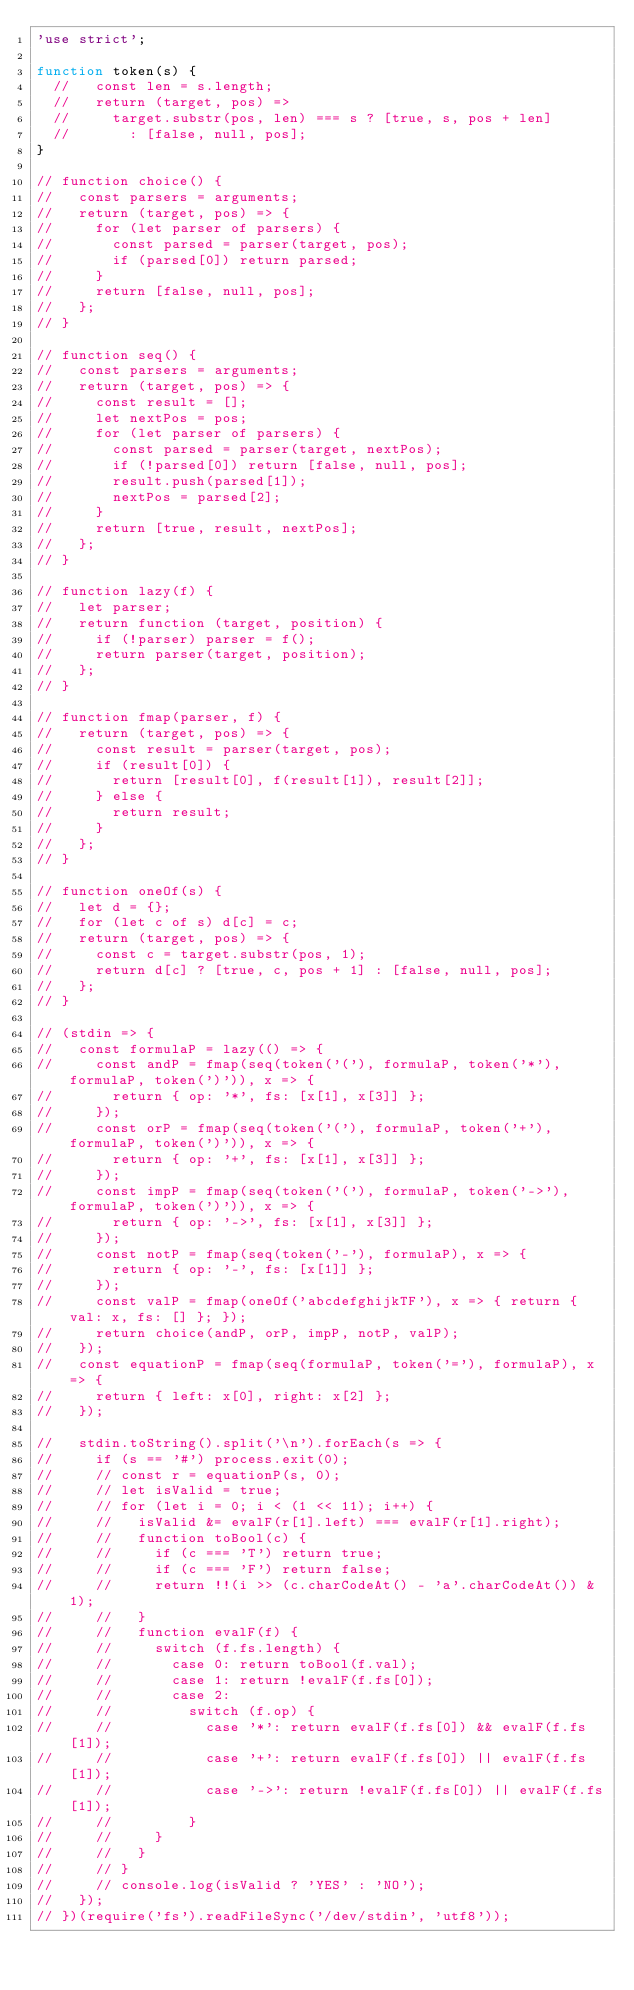Convert code to text. <code><loc_0><loc_0><loc_500><loc_500><_JavaScript_>'use strict';

function token(s) {
  //   const len = s.length;
  //   return (target, pos) =>
  //     target.substr(pos, len) === s ? [true, s, pos + len]
  //       : [false, null, pos];
}

// function choice() {
//   const parsers = arguments;
//   return (target, pos) => {
//     for (let parser of parsers) {
//       const parsed = parser(target, pos);
//       if (parsed[0]) return parsed;
//     }
//     return [false, null, pos];
//   };
// }

// function seq() {
//   const parsers = arguments;
//   return (target, pos) => {
//     const result = [];
//     let nextPos = pos;
//     for (let parser of parsers) {
//       const parsed = parser(target, nextPos);
//       if (!parsed[0]) return [false, null, pos];
//       result.push(parsed[1]);
//       nextPos = parsed[2];
//     }
//     return [true, result, nextPos];
//   };
// }

// function lazy(f) {
//   let parser;
//   return function (target, position) {
//     if (!parser) parser = f();
//     return parser(target, position);
//   };
// }

// function fmap(parser, f) {
//   return (target, pos) => {
//     const result = parser(target, pos);
//     if (result[0]) {
//       return [result[0], f(result[1]), result[2]];
//     } else {
//       return result;
//     }
//   };
// }

// function oneOf(s) {
//   let d = {};
//   for (let c of s) d[c] = c;
//   return (target, pos) => {
//     const c = target.substr(pos, 1);
//     return d[c] ? [true, c, pos + 1] : [false, null, pos];
//   };
// }

// (stdin => {
//   const formulaP = lazy(() => {
//     const andP = fmap(seq(token('('), formulaP, token('*'), formulaP, token(')')), x => {
//       return { op: '*', fs: [x[1], x[3]] };
//     });
//     const orP = fmap(seq(token('('), formulaP, token('+'), formulaP, token(')')), x => {
//       return { op: '+', fs: [x[1], x[3]] };
//     });
//     const impP = fmap(seq(token('('), formulaP, token('->'), formulaP, token(')')), x => {
//       return { op: '->', fs: [x[1], x[3]] };
//     });
//     const notP = fmap(seq(token('-'), formulaP), x => {
//       return { op: '-', fs: [x[1]] };
//     });
//     const valP = fmap(oneOf('abcdefghijkTF'), x => { return { val: x, fs: [] }; });
//     return choice(andP, orP, impP, notP, valP);
//   });
//   const equationP = fmap(seq(formulaP, token('='), formulaP), x => {
//     return { left: x[0], right: x[2] };
//   });

//   stdin.toString().split('\n').forEach(s => {
//     if (s == '#') process.exit(0);
//     // const r = equationP(s, 0);
//     // let isValid = true;
//     // for (let i = 0; i < (1 << 11); i++) {
//     //   isValid &= evalF(r[1].left) === evalF(r[1].right);
//     //   function toBool(c) {
//     //     if (c === 'T') return true;
//     //     if (c === 'F') return false;
//     //     return !!(i >> (c.charCodeAt() - 'a'.charCodeAt()) & 1);
//     //   }
//     //   function evalF(f) {
//     //     switch (f.fs.length) {
//     //       case 0: return toBool(f.val);
//     //       case 1: return !evalF(f.fs[0]);
//     //       case 2:
//     //         switch (f.op) {
//     //           case '*': return evalF(f.fs[0]) && evalF(f.fs[1]);
//     //           case '+': return evalF(f.fs[0]) || evalF(f.fs[1]);
//     //           case '->': return !evalF(f.fs[0]) || evalF(f.fs[1]);
//     //         }
//     //     }
//     //   }
//     // }
//     // console.log(isValid ? 'YES' : 'NO');
//   });
// })(require('fs').readFileSync('/dev/stdin', 'utf8'));</code> 